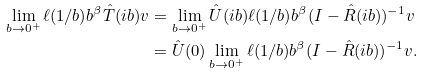Convert formula to latex. <formula><loc_0><loc_0><loc_500><loc_500>\lim _ { b \to 0 ^ { + } } \ell ( 1 / b ) b ^ { \beta } \hat { T } ( i b ) v & = \lim _ { b \to 0 ^ { + } } \hat { U } ( i b ) \ell ( 1 / b ) b ^ { \beta } ( I - \hat { R } ( i b ) ) ^ { - 1 } v \\ & = \hat { U } ( 0 ) \lim _ { b \to 0 ^ { + } } \ell ( 1 / b ) b ^ { \beta } ( I - \hat { R } ( i b ) ) ^ { - 1 } v .</formula> 